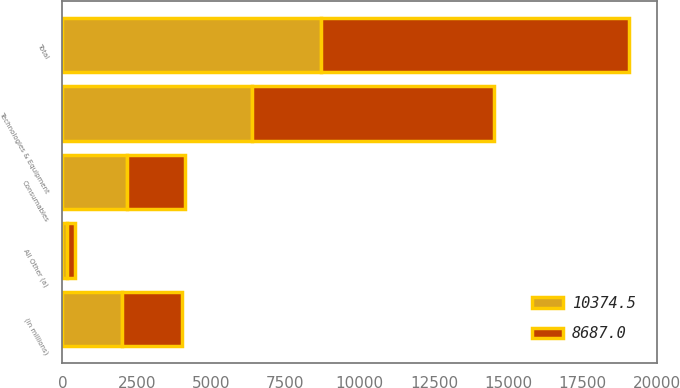Convert chart to OTSL. <chart><loc_0><loc_0><loc_500><loc_500><stacked_bar_chart><ecel><fcel>(in millions)<fcel>Technologies & Equipment<fcel>Consumables<fcel>All Other (a)<fcel>Total<nl><fcel>10374.5<fcel>2018<fcel>6380.2<fcel>2158.4<fcel>148.4<fcel>8687<nl><fcel>8687<fcel>2017<fcel>8130.6<fcel>1965.1<fcel>278.8<fcel>10374.5<nl></chart> 